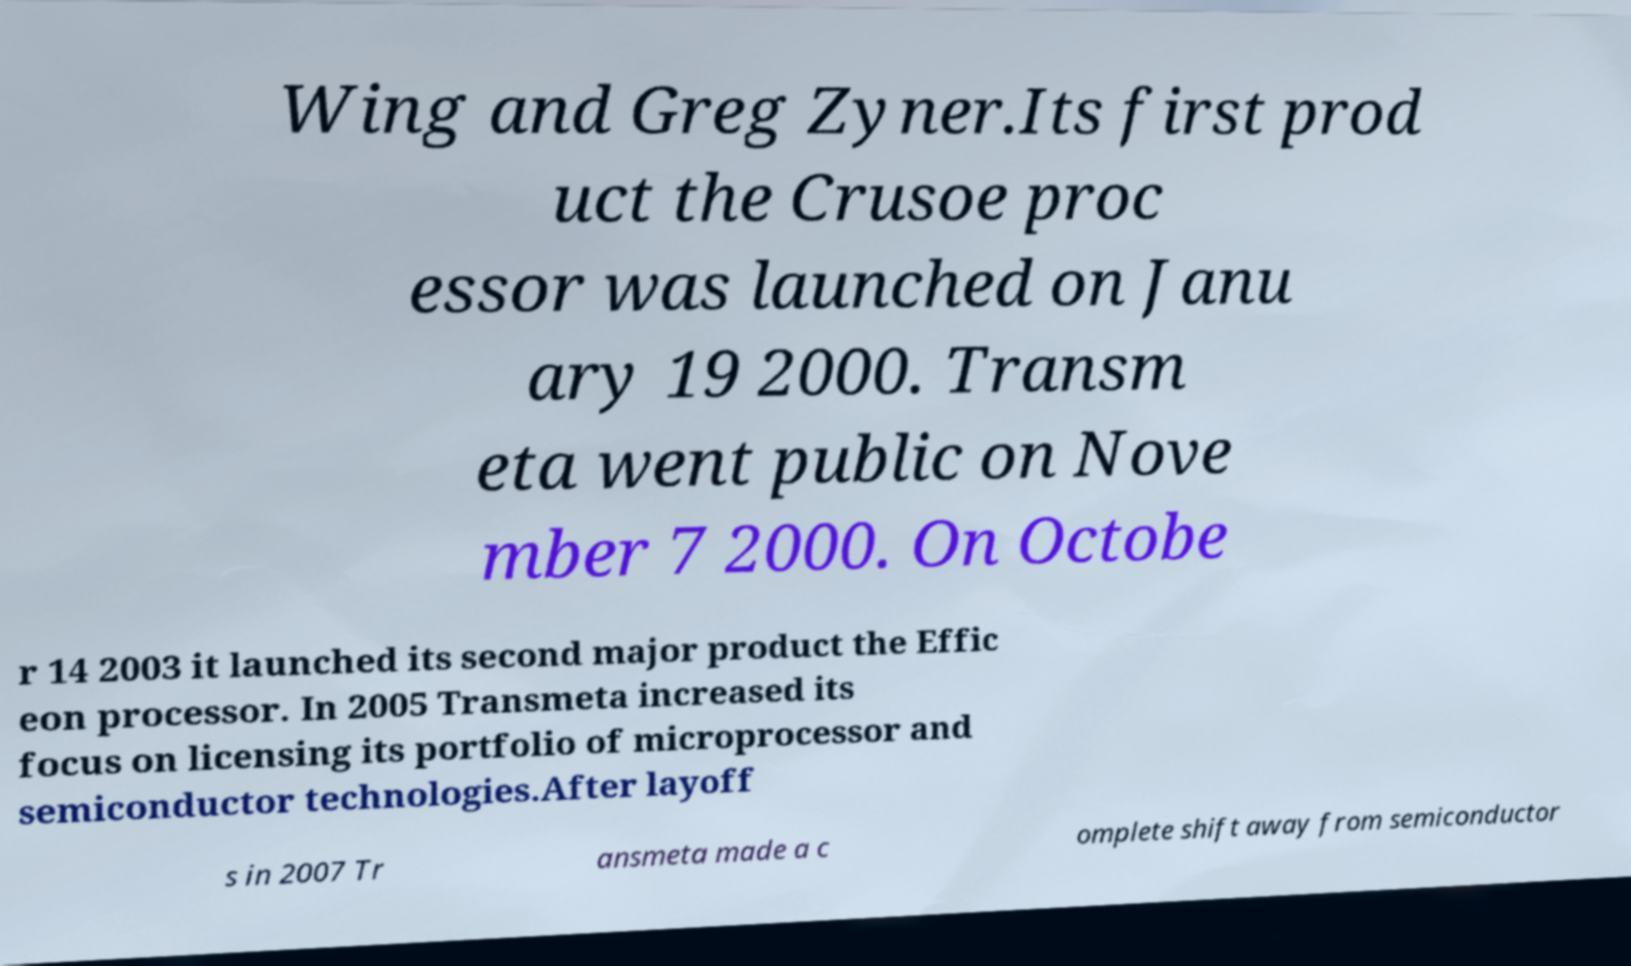I need the written content from this picture converted into text. Can you do that? Wing and Greg Zyner.Its first prod uct the Crusoe proc essor was launched on Janu ary 19 2000. Transm eta went public on Nove mber 7 2000. On Octobe r 14 2003 it launched its second major product the Effic eon processor. In 2005 Transmeta increased its focus on licensing its portfolio of microprocessor and semiconductor technologies.After layoff s in 2007 Tr ansmeta made a c omplete shift away from semiconductor 